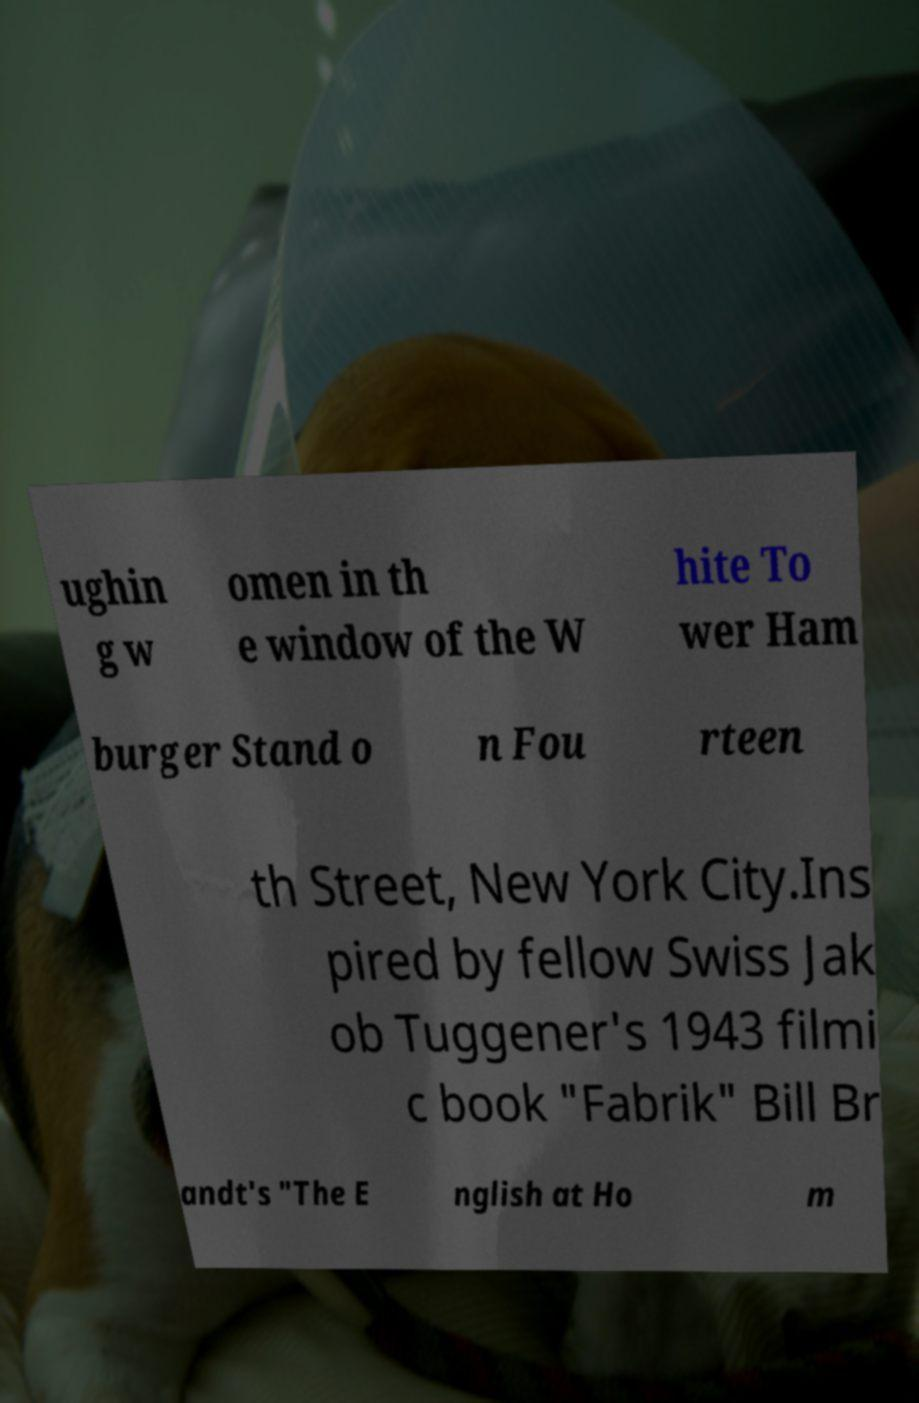Could you extract and type out the text from this image? ughin g w omen in th e window of the W hite To wer Ham burger Stand o n Fou rteen th Street, New York City.Ins pired by fellow Swiss Jak ob Tuggener's 1943 filmi c book "Fabrik" Bill Br andt's "The E nglish at Ho m 